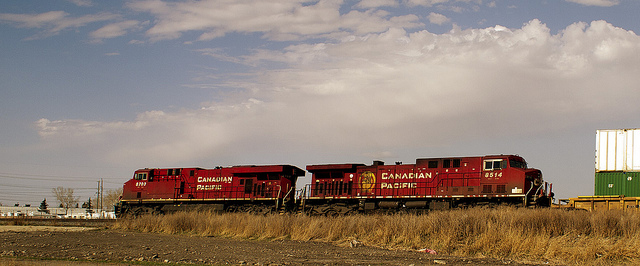Please transcribe the text information in this image. PACIFIC CANACIAN PACIFIC 